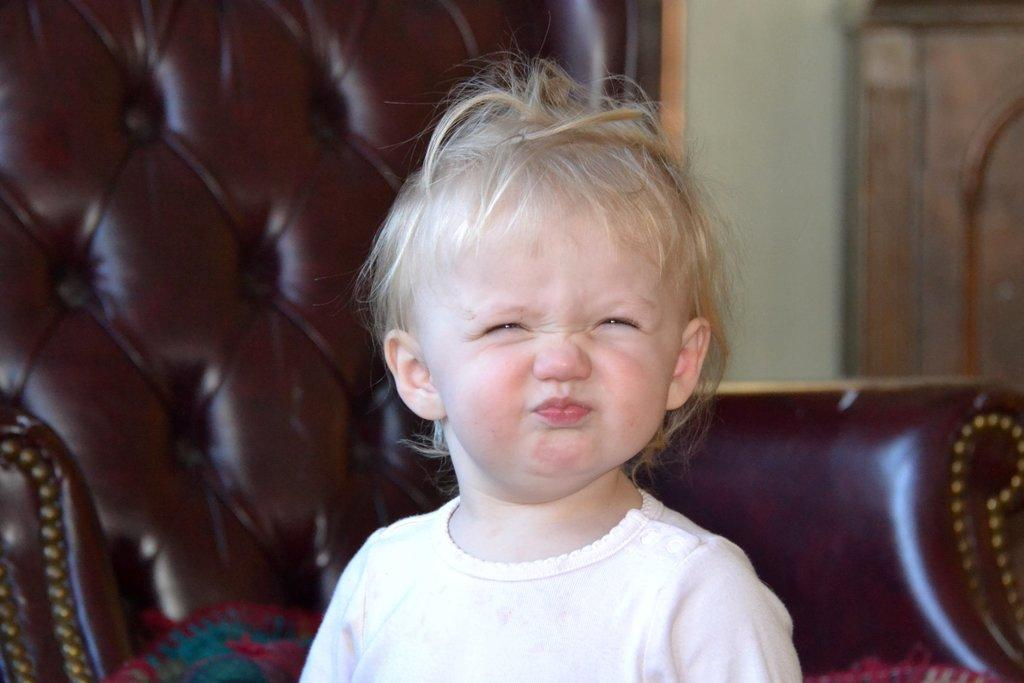What is the main subject of the image? There is a child in the image. What is located behind the child? There is a couch behind the child. What can be seen in the background of the image? There is a wall visible in the image. What type of furniture is present in the top right of the image? There is a cupboard in the top right of the image. What language is the child speaking in the image? The image does not provide any information about the language being spoken by the child. How many spiders are crawling on the wall in the image? There are no spiders visible in the image; only the child, couch, wall, and cupboard are present. 